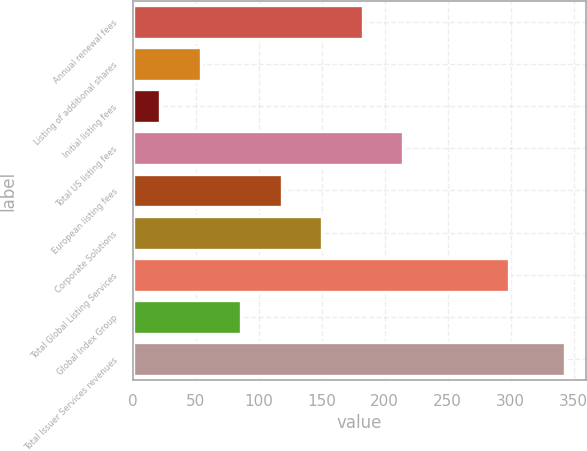Convert chart to OTSL. <chart><loc_0><loc_0><loc_500><loc_500><bar_chart><fcel>Annual renewal fees<fcel>Listing of additional shares<fcel>Initial listing fees<fcel>Total US listing fees<fcel>European listing fees<fcel>Corporate Solutions<fcel>Total Global Listing Services<fcel>Global Index Group<fcel>Total Issuer Services revenues<nl><fcel>182.5<fcel>54.1<fcel>22<fcel>214.6<fcel>118.3<fcel>150.4<fcel>299<fcel>86.2<fcel>343<nl></chart> 